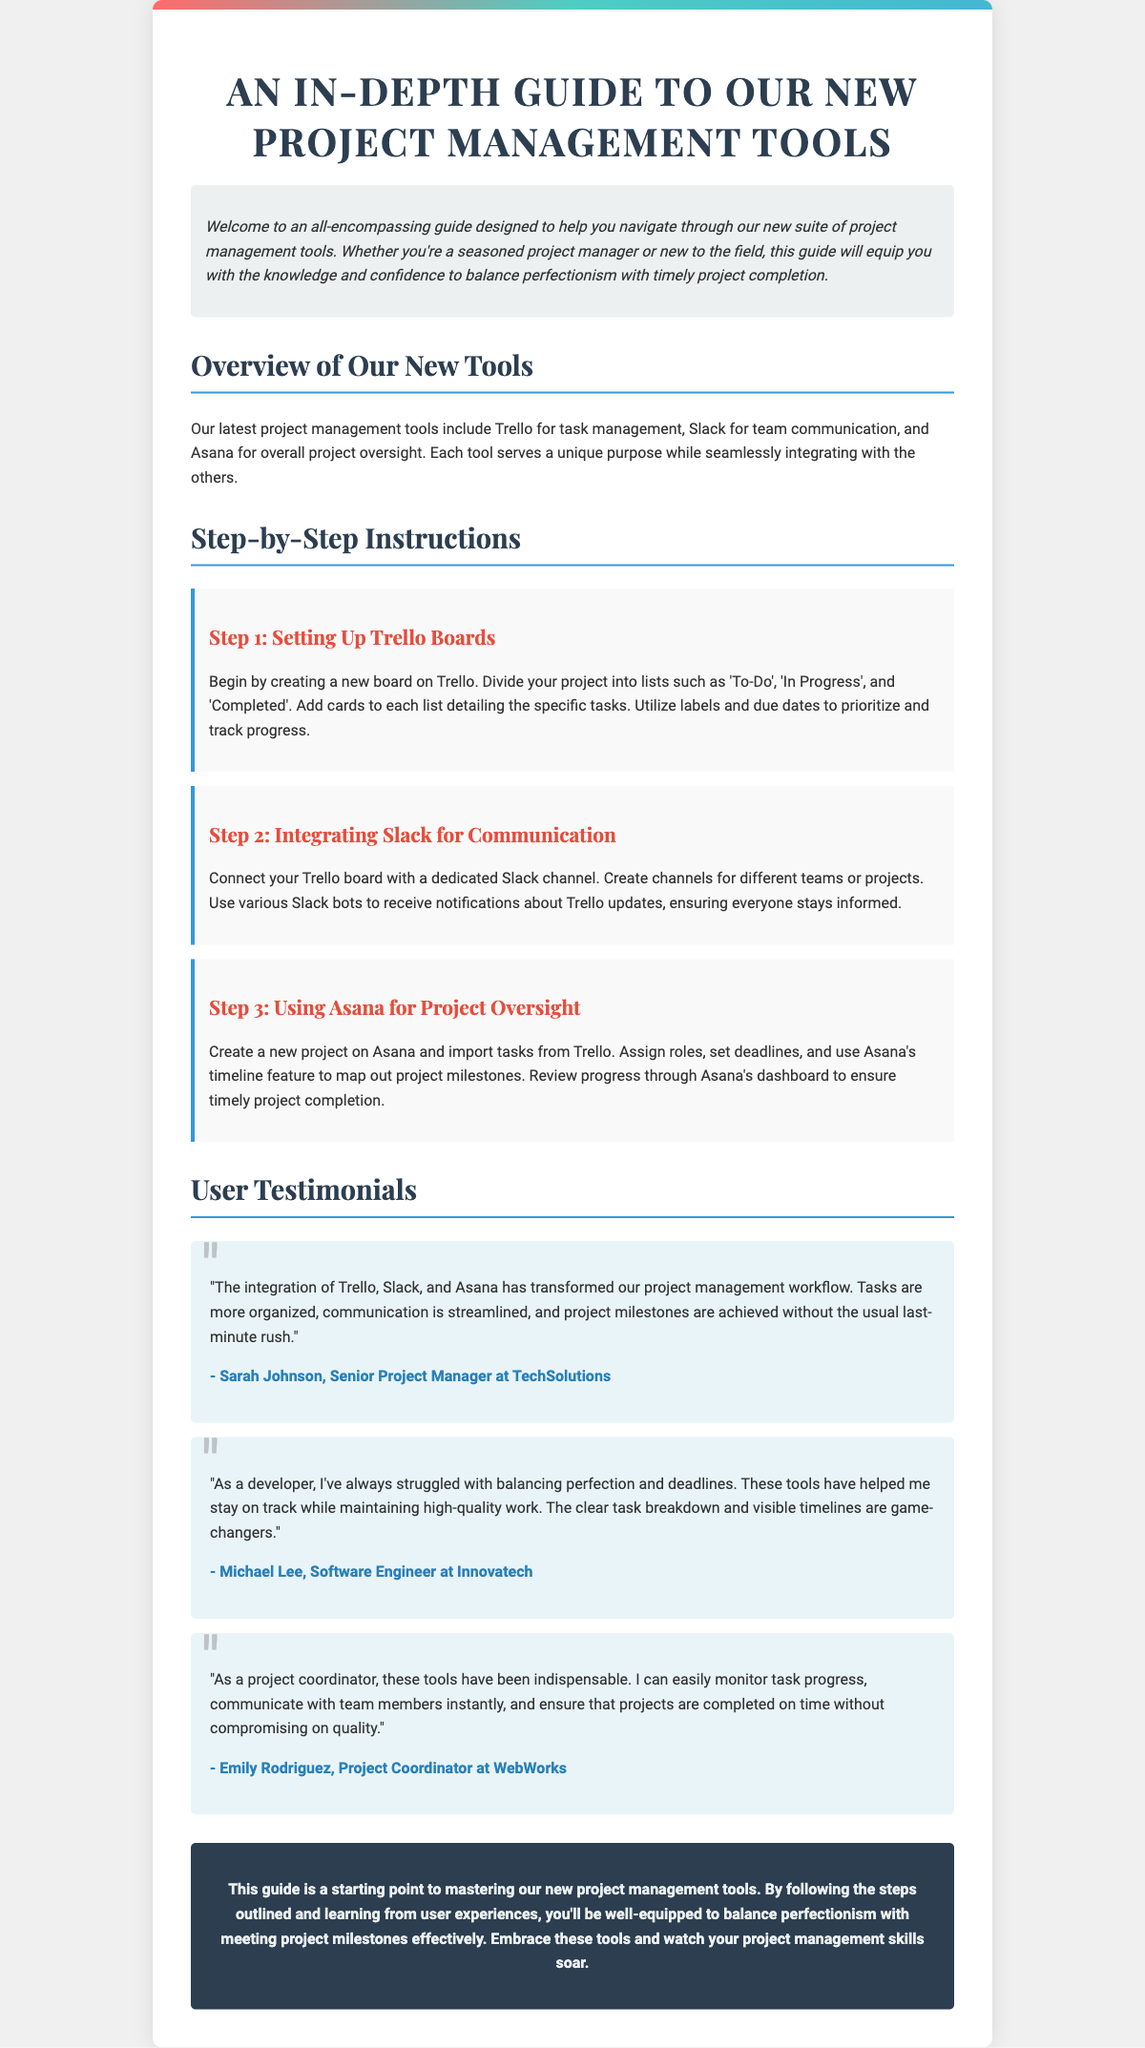What is the title of the document? The title is presented at the top of the document, summarizing its purpose.
Answer: An In-Depth Guide to Our New Project Management Tools Who is the author of the first testimonial? The author of the first testimonial is mentioned below their quote.
Answer: Sarah Johnson What tool is mentioned for task management? The document explicitly states which tool is used for task management.
Answer: Trello How many steps are outlined in the instructions? The number of steps is revealed through the headings for the step-by-step instructions.
Answer: 3 What colors are used in the gradient at the top of the playbill? The gradient colors are listed in the styling section of the document.
Answer: Red, green, blue What integration is suggested for communication? The document specifically mentions how to enhance communication among team members.
Answer: Slack Which feature in Asana helps with timeline mapping? The document outlines the specific feature in Asana that aids project oversight.
Answer: Timeline feature What role does Emily Rodriguez hold? Emily's position is mentioned in her testimonial, showcasing her professional identity.
Answer: Project Coordinator What has transformed the project management workflow according to the testimonials? The testimonials highlight the impact that the tools have had on their workflow.
Answer: Integration of Trello, Slack, and Asana 